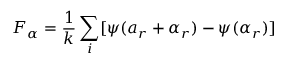<formula> <loc_0><loc_0><loc_500><loc_500>F _ { \alpha } = \frac { 1 } { k } \sum _ { i } [ \psi ( a _ { r } + \alpha _ { r } ) - \psi ( \alpha _ { r } ) ]</formula> 